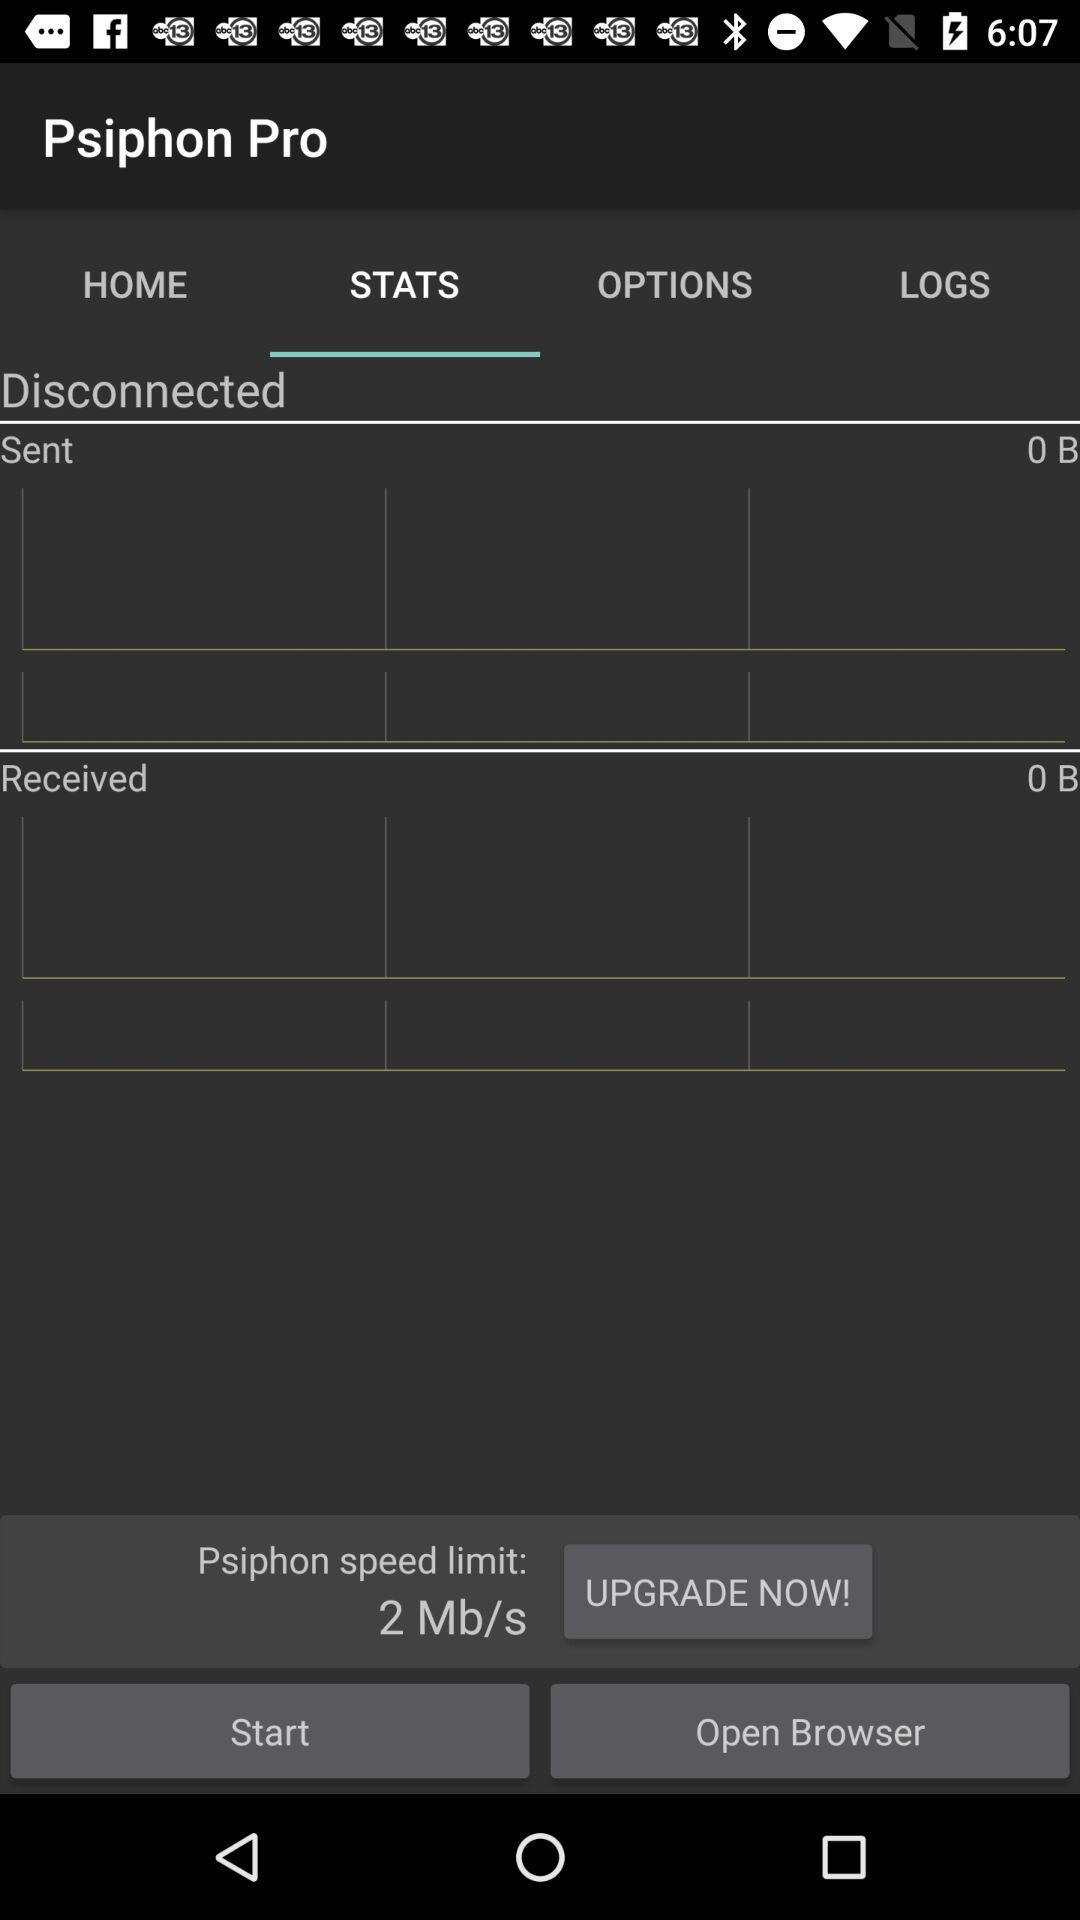How much data is received? The received data is 0 B. 